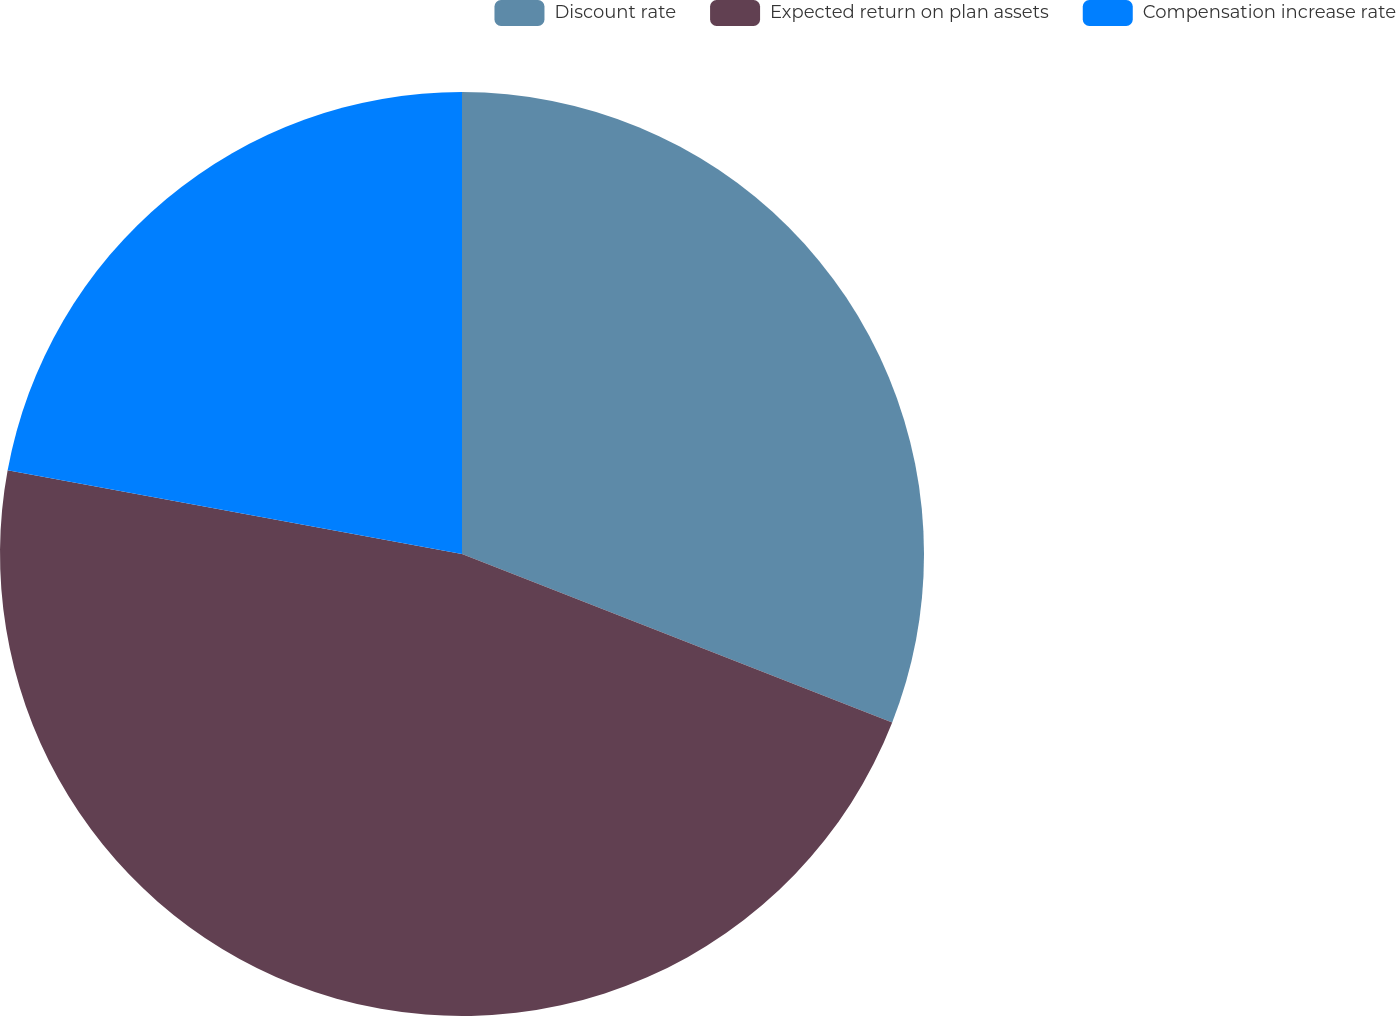Convert chart. <chart><loc_0><loc_0><loc_500><loc_500><pie_chart><fcel>Discount rate<fcel>Expected return on plan assets<fcel>Compensation increase rate<nl><fcel>30.94%<fcel>46.96%<fcel>22.1%<nl></chart> 